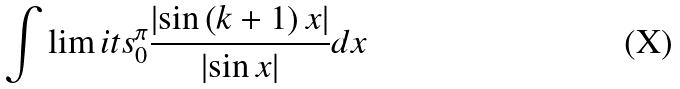Convert formula to latex. <formula><loc_0><loc_0><loc_500><loc_500>\int \lim i t s _ { 0 } ^ { \pi } \frac { \left | \sin \left ( k + 1 \right ) x \right | } { \left | \sin x \right | } d x</formula> 